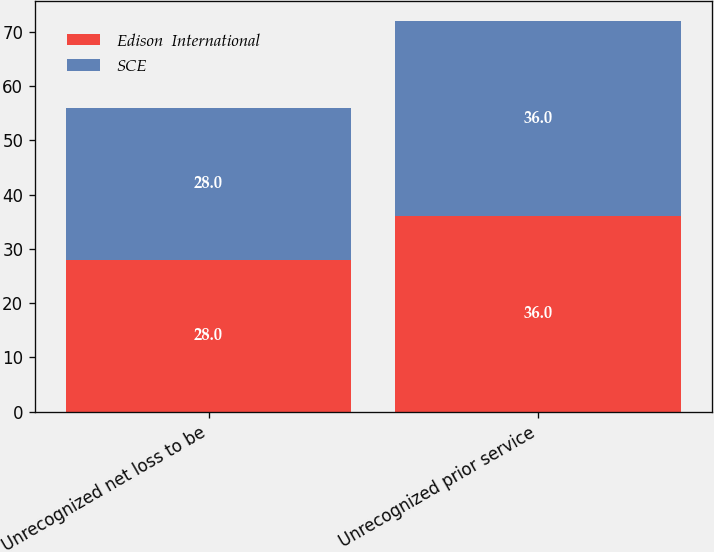<chart> <loc_0><loc_0><loc_500><loc_500><stacked_bar_chart><ecel><fcel>Unrecognized net loss to be<fcel>Unrecognized prior service<nl><fcel>Edison  International<fcel>28<fcel>36<nl><fcel>SCE<fcel>28<fcel>36<nl></chart> 